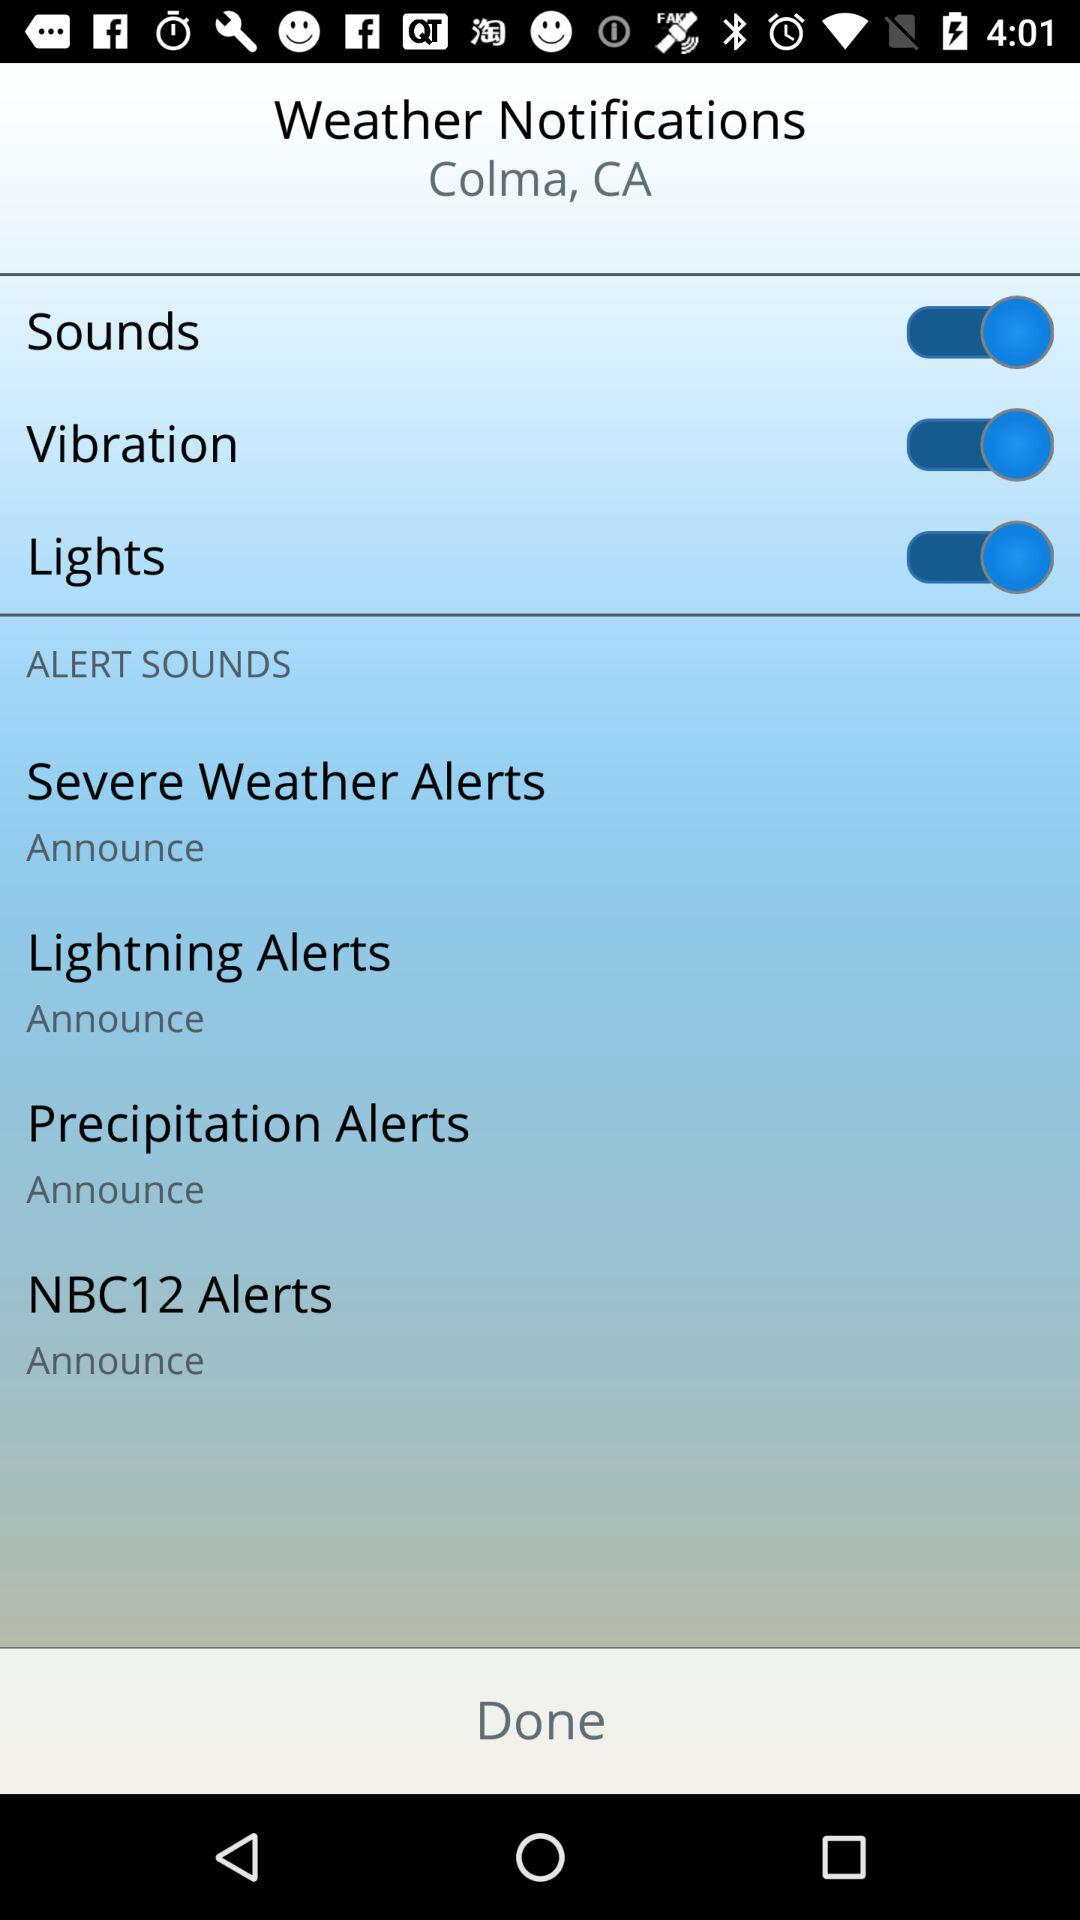Which options are enabled in the application? The enabled options in the applications are "Sounds", "Vibration" and "Lights". 